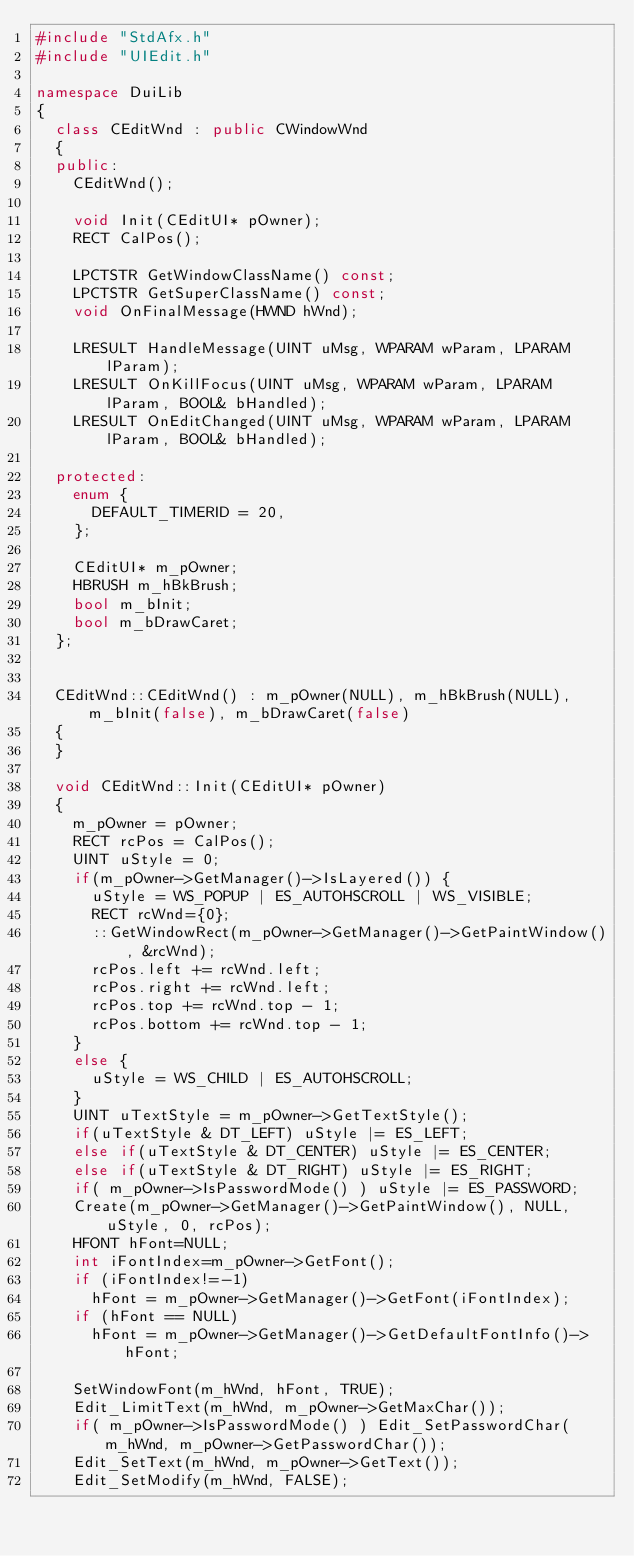<code> <loc_0><loc_0><loc_500><loc_500><_C++_>#include "StdAfx.h"
#include "UIEdit.h"

namespace DuiLib
{
	class CEditWnd : public CWindowWnd
	{
	public:
		CEditWnd();

		void Init(CEditUI* pOwner);
		RECT CalPos();

		LPCTSTR GetWindowClassName() const;
		LPCTSTR GetSuperClassName() const;
		void OnFinalMessage(HWND hWnd);

		LRESULT HandleMessage(UINT uMsg, WPARAM wParam, LPARAM lParam);
		LRESULT OnKillFocus(UINT uMsg, WPARAM wParam, LPARAM lParam, BOOL& bHandled);
		LRESULT OnEditChanged(UINT uMsg, WPARAM wParam, LPARAM lParam, BOOL& bHandled);

	protected:
		enum { 
			DEFAULT_TIMERID = 20,
		};

		CEditUI* m_pOwner;
		HBRUSH m_hBkBrush;
		bool m_bInit;
		bool m_bDrawCaret;
	};


	CEditWnd::CEditWnd() : m_pOwner(NULL), m_hBkBrush(NULL), m_bInit(false), m_bDrawCaret(false)
	{
	}

	void CEditWnd::Init(CEditUI* pOwner)
	{
		m_pOwner = pOwner;
		RECT rcPos = CalPos();
		UINT uStyle = 0;
		if(m_pOwner->GetManager()->IsLayered()) {
			uStyle = WS_POPUP | ES_AUTOHSCROLL | WS_VISIBLE;
			RECT rcWnd={0};
			::GetWindowRect(m_pOwner->GetManager()->GetPaintWindow(), &rcWnd);
			rcPos.left += rcWnd.left;
			rcPos.right += rcWnd.left;
			rcPos.top += rcWnd.top - 1;
			rcPos.bottom += rcWnd.top - 1;
		}
		else {
			uStyle = WS_CHILD | ES_AUTOHSCROLL;
		}
		UINT uTextStyle = m_pOwner->GetTextStyle();
		if(uTextStyle & DT_LEFT) uStyle |= ES_LEFT;
		else if(uTextStyle & DT_CENTER) uStyle |= ES_CENTER;
		else if(uTextStyle & DT_RIGHT) uStyle |= ES_RIGHT;
		if( m_pOwner->IsPasswordMode() ) uStyle |= ES_PASSWORD;
		Create(m_pOwner->GetManager()->GetPaintWindow(), NULL, uStyle, 0, rcPos);
		HFONT hFont=NULL;
		int iFontIndex=m_pOwner->GetFont();
		if (iFontIndex!=-1)
			hFont = m_pOwner->GetManager()->GetFont(iFontIndex);
		if (hFont == NULL)
			hFont = m_pOwner->GetManager()->GetDefaultFontInfo()->hFont;

		SetWindowFont(m_hWnd, hFont, TRUE);
		Edit_LimitText(m_hWnd, m_pOwner->GetMaxChar());
		if( m_pOwner->IsPasswordMode() ) Edit_SetPasswordChar(m_hWnd, m_pOwner->GetPasswordChar());
		Edit_SetText(m_hWnd, m_pOwner->GetText());
		Edit_SetModify(m_hWnd, FALSE);</code> 